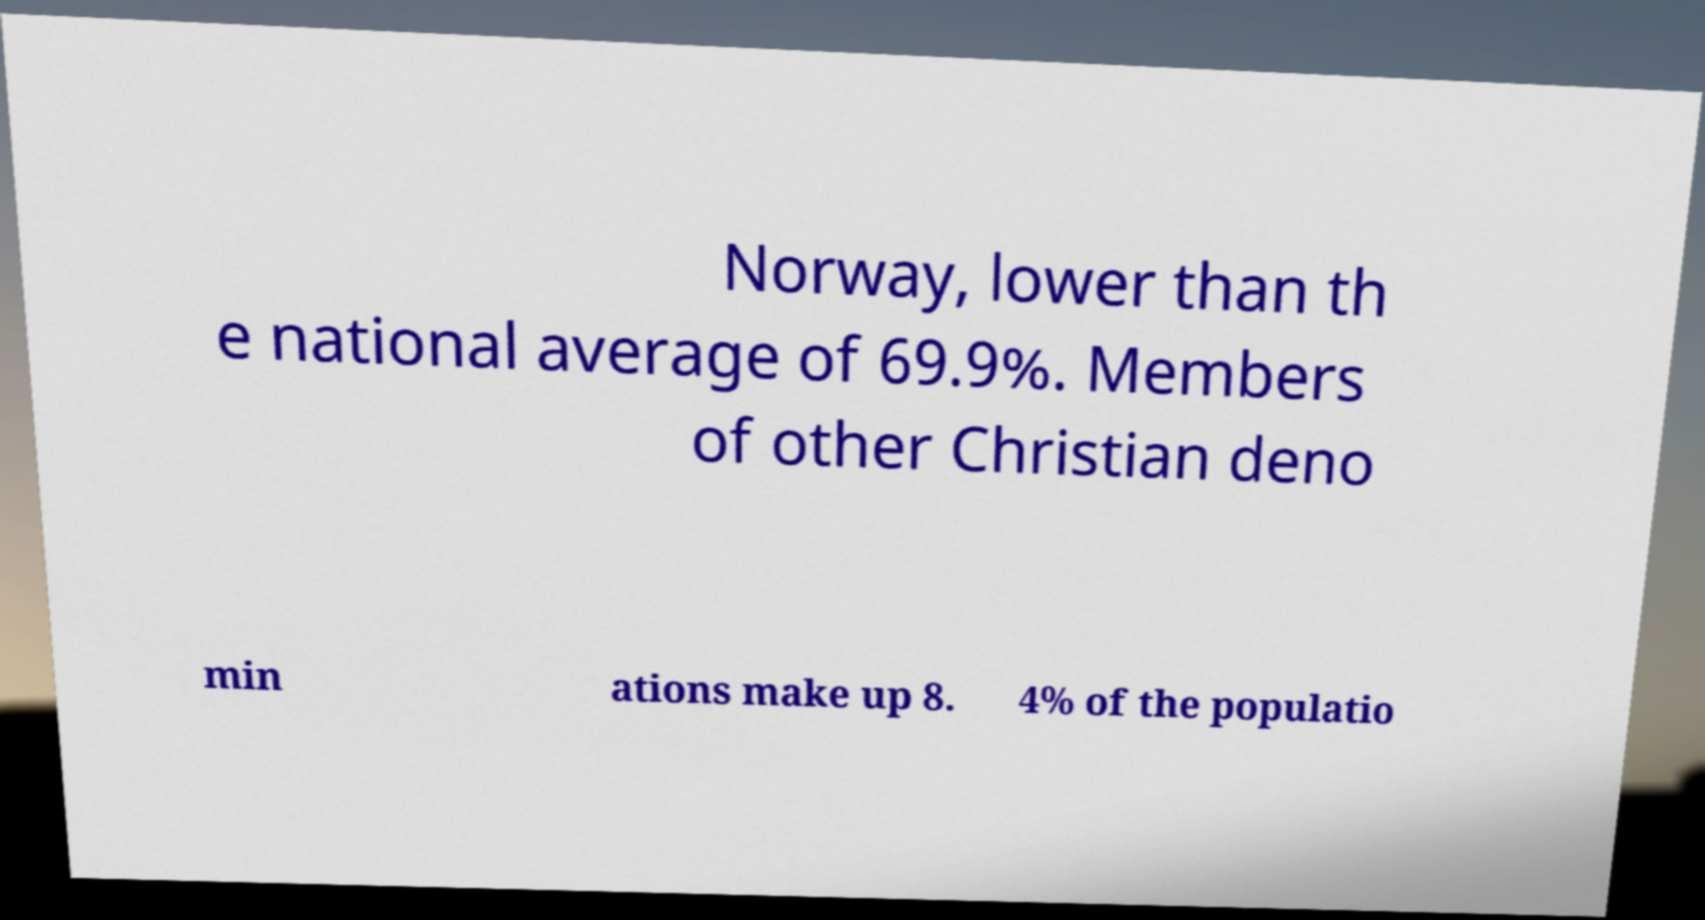What messages or text are displayed in this image? I need them in a readable, typed format. Norway, lower than th e national average of 69.9%. Members of other Christian deno min ations make up 8. 4% of the populatio 